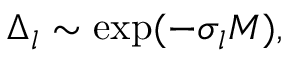<formula> <loc_0><loc_0><loc_500><loc_500>\Delta _ { l } \sim \exp ( - \sigma _ { l } M ) ,</formula> 